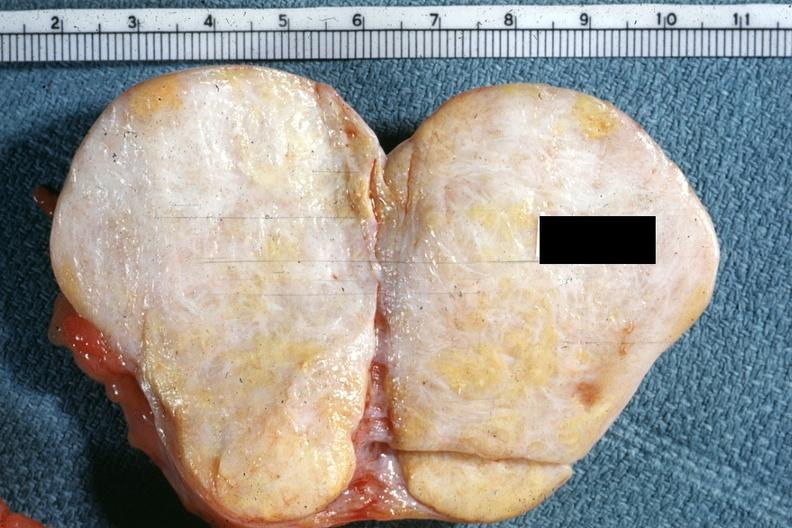how is there no present to indicate the location of the tumor mass?
Answer the question using a single word or phrase. Ovary 